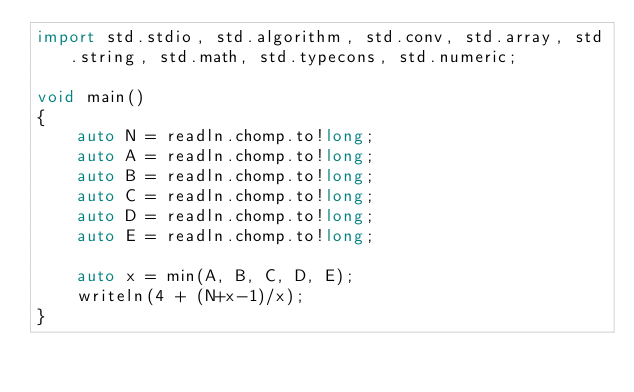Convert code to text. <code><loc_0><loc_0><loc_500><loc_500><_D_>import std.stdio, std.algorithm, std.conv, std.array, std.string, std.math, std.typecons, std.numeric;

void main()
{
    auto N = readln.chomp.to!long;
    auto A = readln.chomp.to!long;
    auto B = readln.chomp.to!long;
    auto C = readln.chomp.to!long;
    auto D = readln.chomp.to!long;
    auto E = readln.chomp.to!long;

    auto x = min(A, B, C, D, E);
    writeln(4 + (N+x-1)/x);
}</code> 